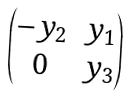Convert formula to latex. <formula><loc_0><loc_0><loc_500><loc_500>\begin{pmatrix} - y _ { 2 } & y _ { 1 } \\ 0 & y _ { 3 } \end{pmatrix}</formula> 